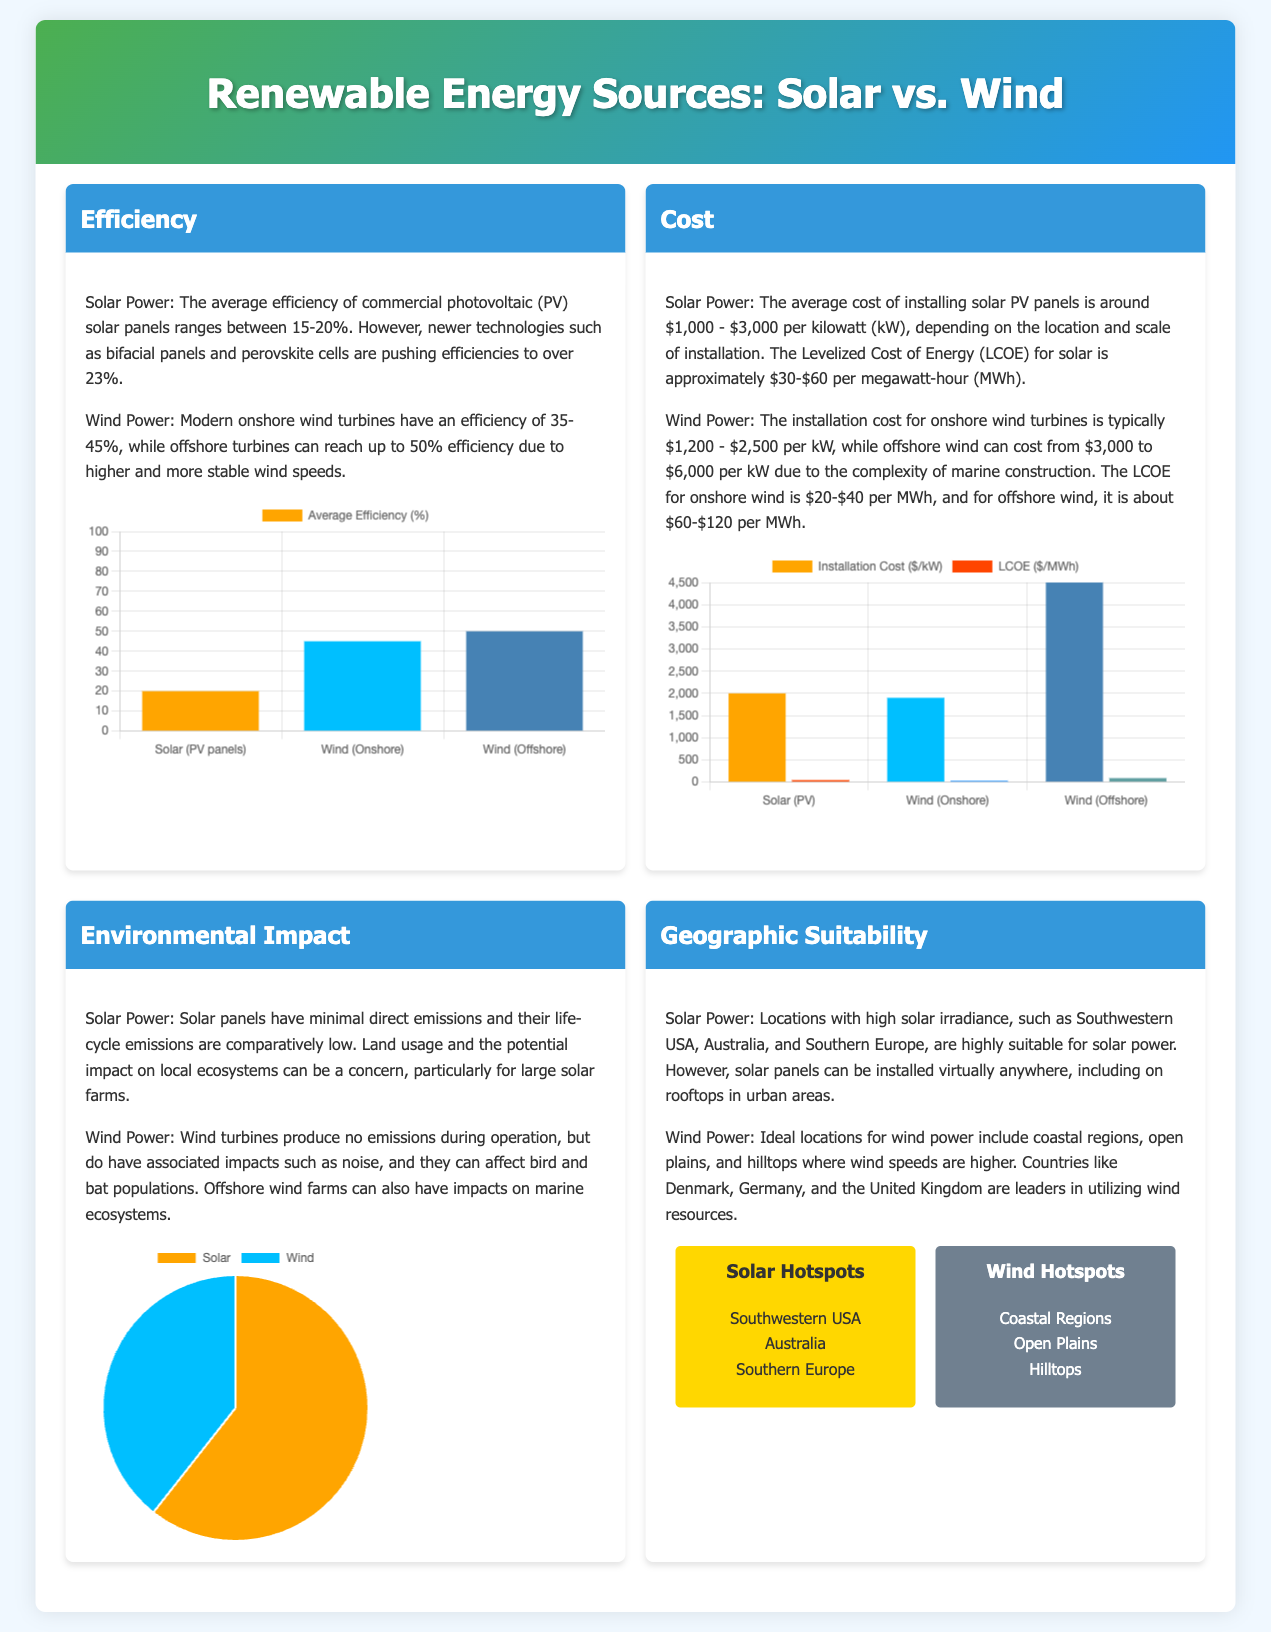What is the average efficiency of solar panels? The average efficiency of commercial photovoltaic (PV) solar panels ranges between 15-20%, and newer technologies can exceed 23%.
Answer: 20% What is the maximum efficiency for offshore wind turbines? Modern offshore turbines can reach efficiencies up to 50%.
Answer: 50% What is the average installation cost of solar PV panels? The average cost of installing solar PV panels is around $1,000 - $3,000 per kilowatt.
Answer: $2000 What is the Levelized Cost of Energy for onshore wind? The LCOE for onshore wind is approximately $20-$40 per megawatt-hour.
Answer: $30 How many environmental emissions (g CO2-eq/kWh) does solar power generate? Solar panels have a life-cycle emissions of 20 grams CO2-eq per kilowatt-hour.
Answer: 20 Which region is a solar hotspot? Locations like the Southwestern USA, Australia, and Southern Europe are ideal for solar power.
Answer: Southwestern USA What are two key concerns related to wind power's environmental impact? Wind turbines can affect bird and bat populations and produce noise.
Answer: Birds and noise What is the installation cost range for offshore wind? The installation cost for offshore wind can cost from $3,000 to $6,000 per kilowatt.
Answer: $4500 What chart type represents the efficiency comparison of solar and wind? The efficiency comparison is illustrated with a bar chart.
Answer: Bar chart Which regions are considered wind hotspots? Ideal locations for wind power include coastal regions, open plains, and hilltops.
Answer: Coastal regions 